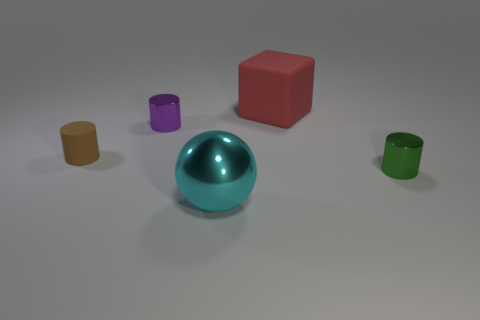Are there any tiny balls that have the same material as the big cyan sphere?
Offer a terse response. No. What material is the red cube that is the same size as the cyan ball?
Your answer should be very brief. Rubber. There is a matte thing left of the big object that is behind the rubber object that is in front of the purple thing; what is its color?
Offer a very short reply. Brown. There is a big thing that is in front of the large red thing; is its shape the same as the matte thing on the right side of the brown cylinder?
Your answer should be compact. No. How many tiny things are there?
Provide a short and direct response. 3. There is a rubber cube that is the same size as the sphere; what is its color?
Keep it short and to the point. Red. Do the large object that is left of the matte cube and the tiny cylinder in front of the brown rubber cylinder have the same material?
Ensure brevity in your answer.  Yes. What size is the shiny cylinder behind the object on the right side of the large cube?
Offer a very short reply. Small. There is a cylinder that is on the left side of the tiny purple object; what is its material?
Offer a very short reply. Rubber. What number of things are either cylinders that are to the right of the cyan metallic object or tiny cylinders behind the green cylinder?
Offer a terse response. 3. 